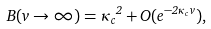<formula> <loc_0><loc_0><loc_500><loc_500>B ( v \to \infty ) = { \kappa _ { c } } ^ { 2 } + O ( e ^ { - 2 \kappa _ { c } v } ) ,</formula> 